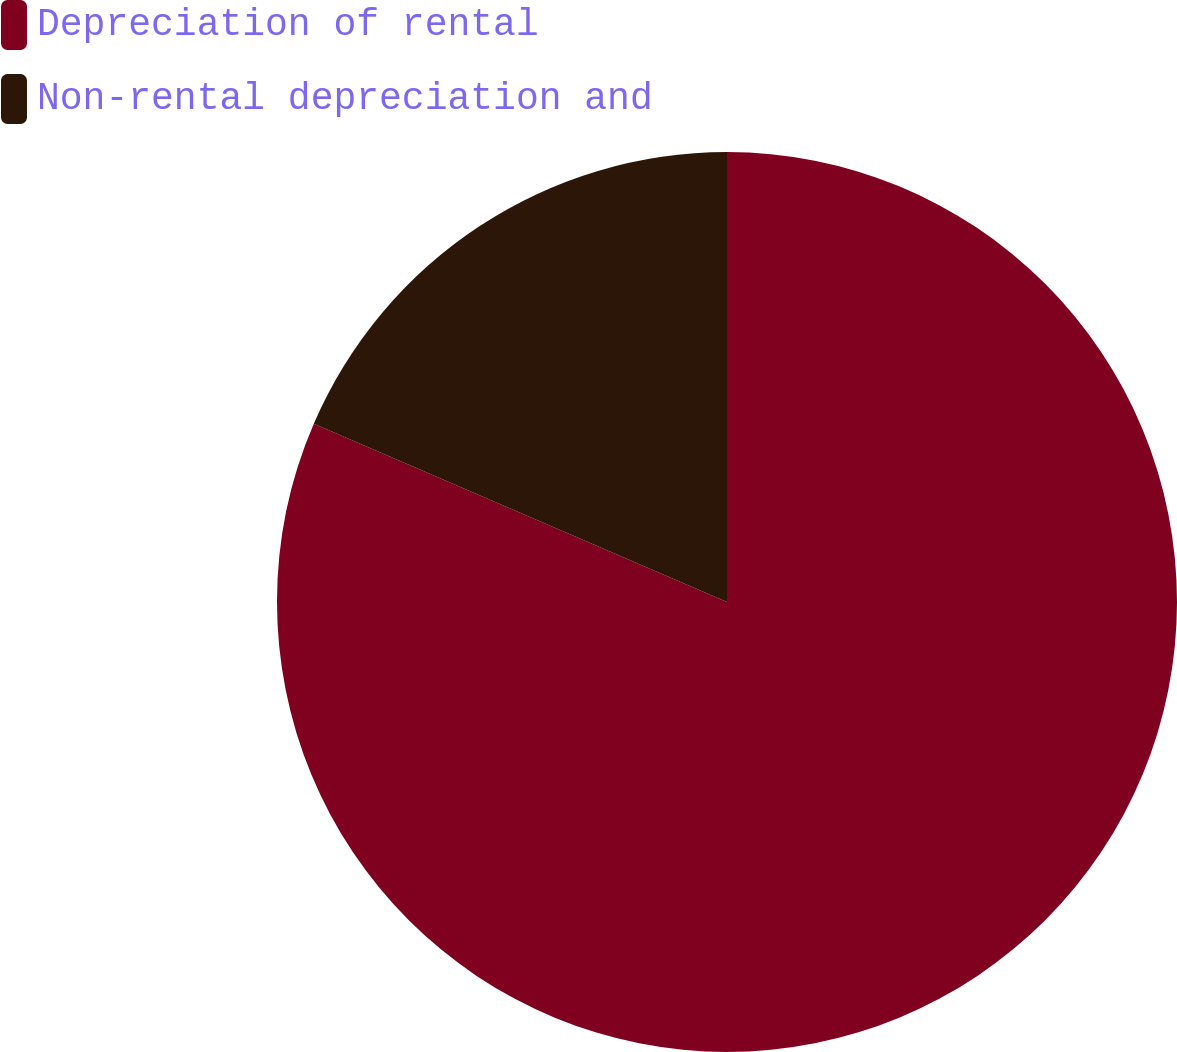Convert chart. <chart><loc_0><loc_0><loc_500><loc_500><pie_chart><fcel>Depreciation of rental<fcel>Non-rental depreciation and<nl><fcel>81.48%<fcel>18.52%<nl></chart> 